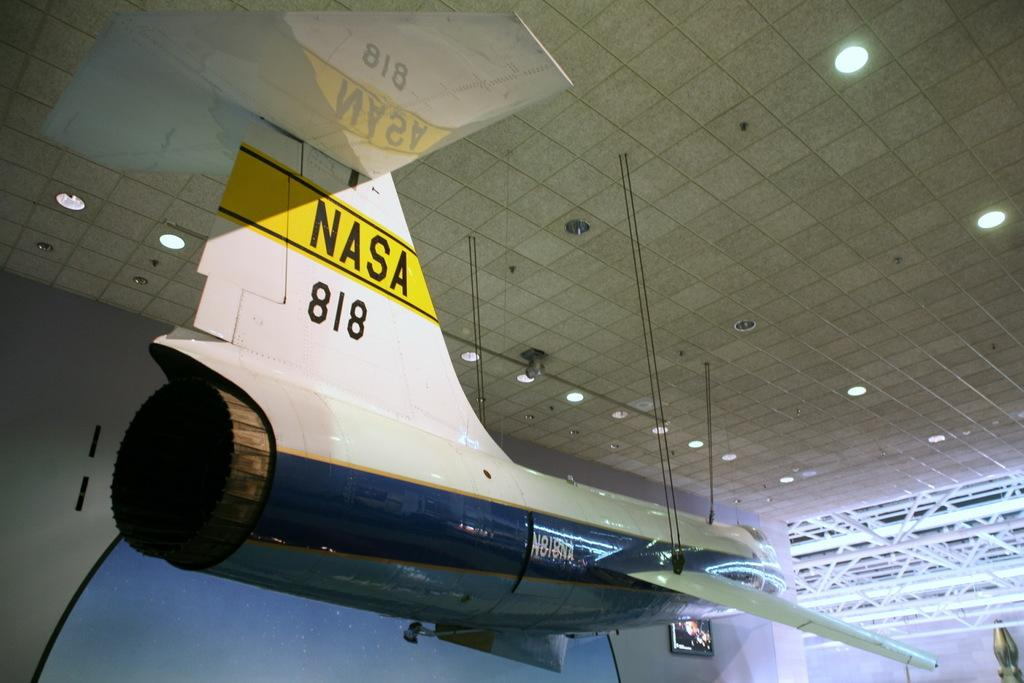<image>
Summarize the visual content of the image. An airplane suspended by chains from the ceiling of a building with NASA 818 on the back of the wing. 